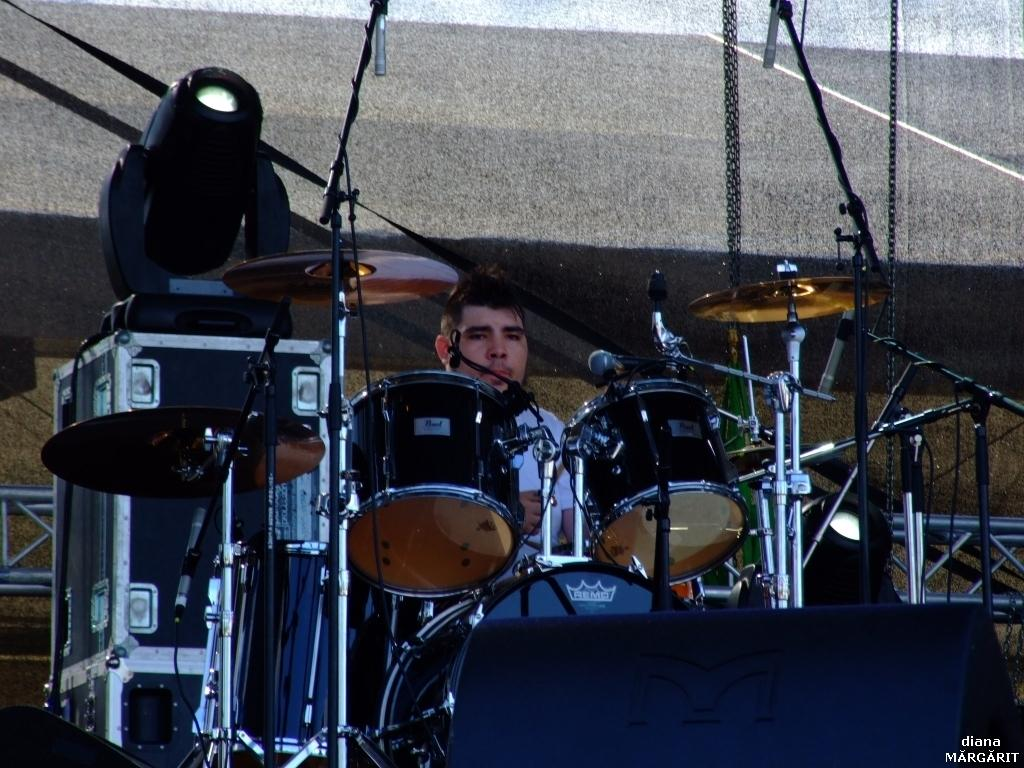What is the main activity being performed in the image? There is a person playing drums in the image. What other musical elements can be seen in the image? There are musical instruments in the image, including speakers, mics, and stands. Are there any cobwebs visible in the image? There is no mention of cobwebs in the provided facts, and therefore we cannot determine if any are present in the image. 